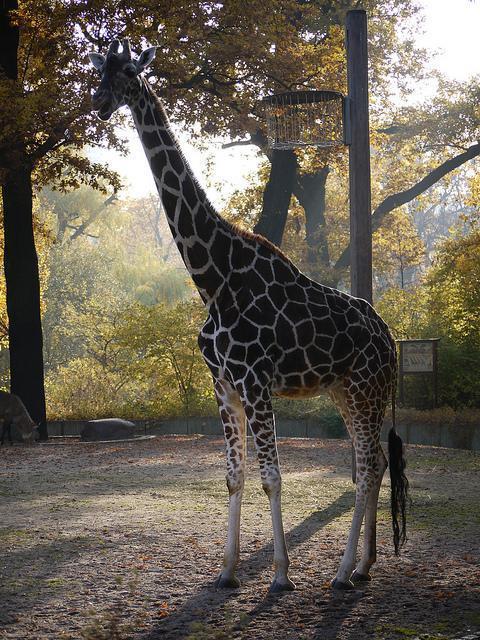How many animals are pictured here?
Give a very brief answer. 1. 